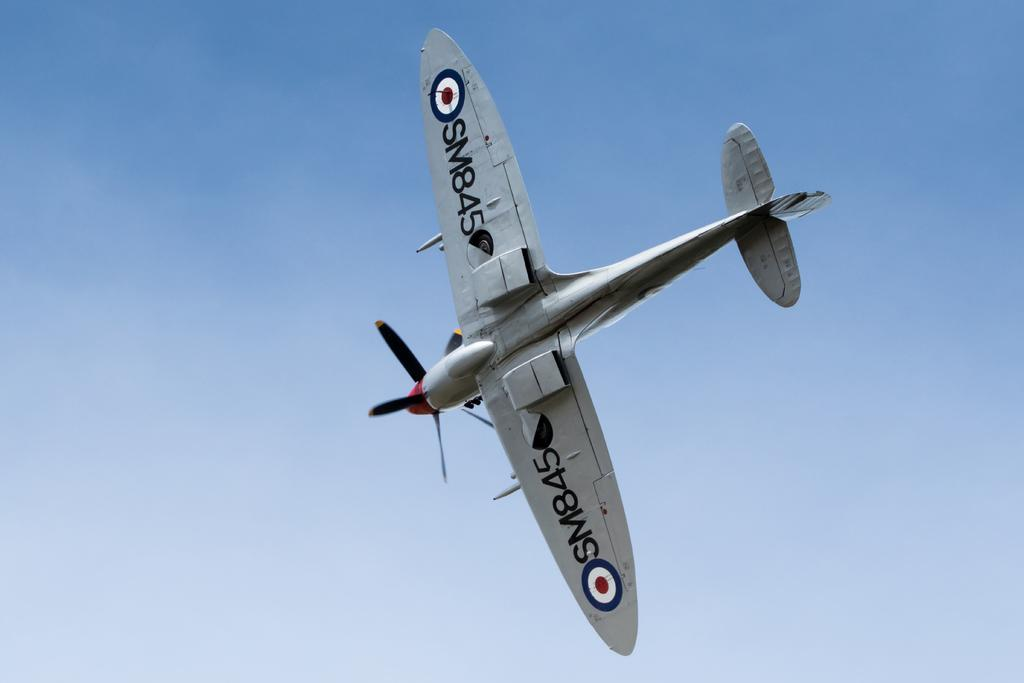<image>
Write a terse but informative summary of the picture. a plane with the letters 845 on the wing of it 